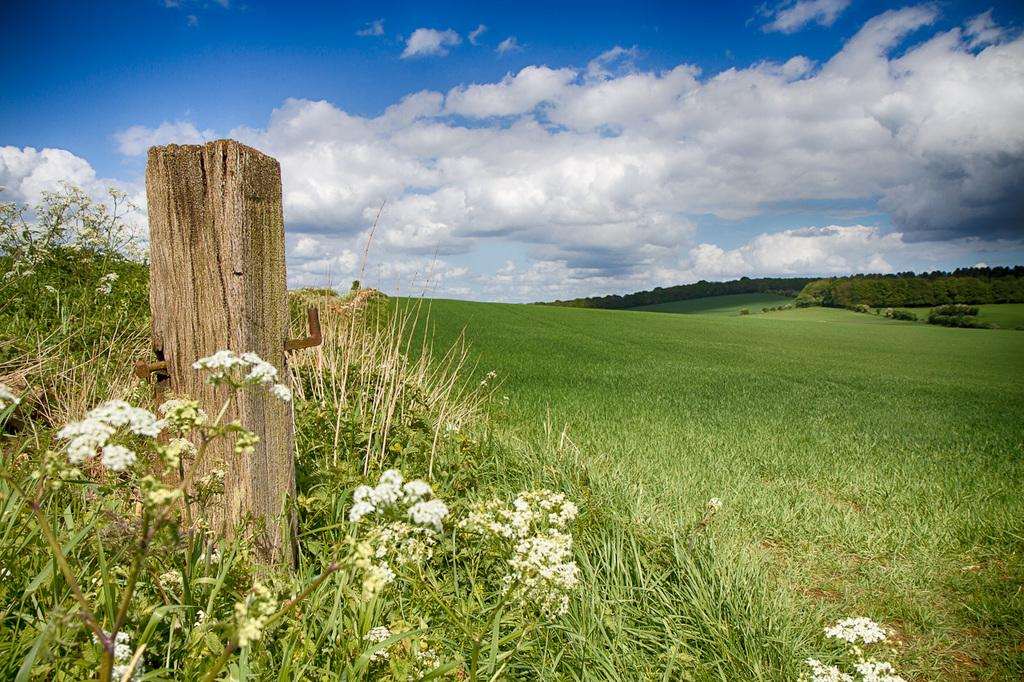What type of living organisms can be seen in the image? There is a group of plants in the image. Can you describe the object made of wood and metal? There is a wood log with metal rods in the image. What can be seen in the background of the image? There is a group of trees and the sky visible in the background of the image. How does the sky appear in the image? The sky appears to be cloudy in the image. How many tomatoes are hanging from the trees in the image? There are no tomatoes present in the image; it features a group of plants and trees, but no tomatoes. What type of birds can be seen flying in the image? There are no birds visible in the image. 